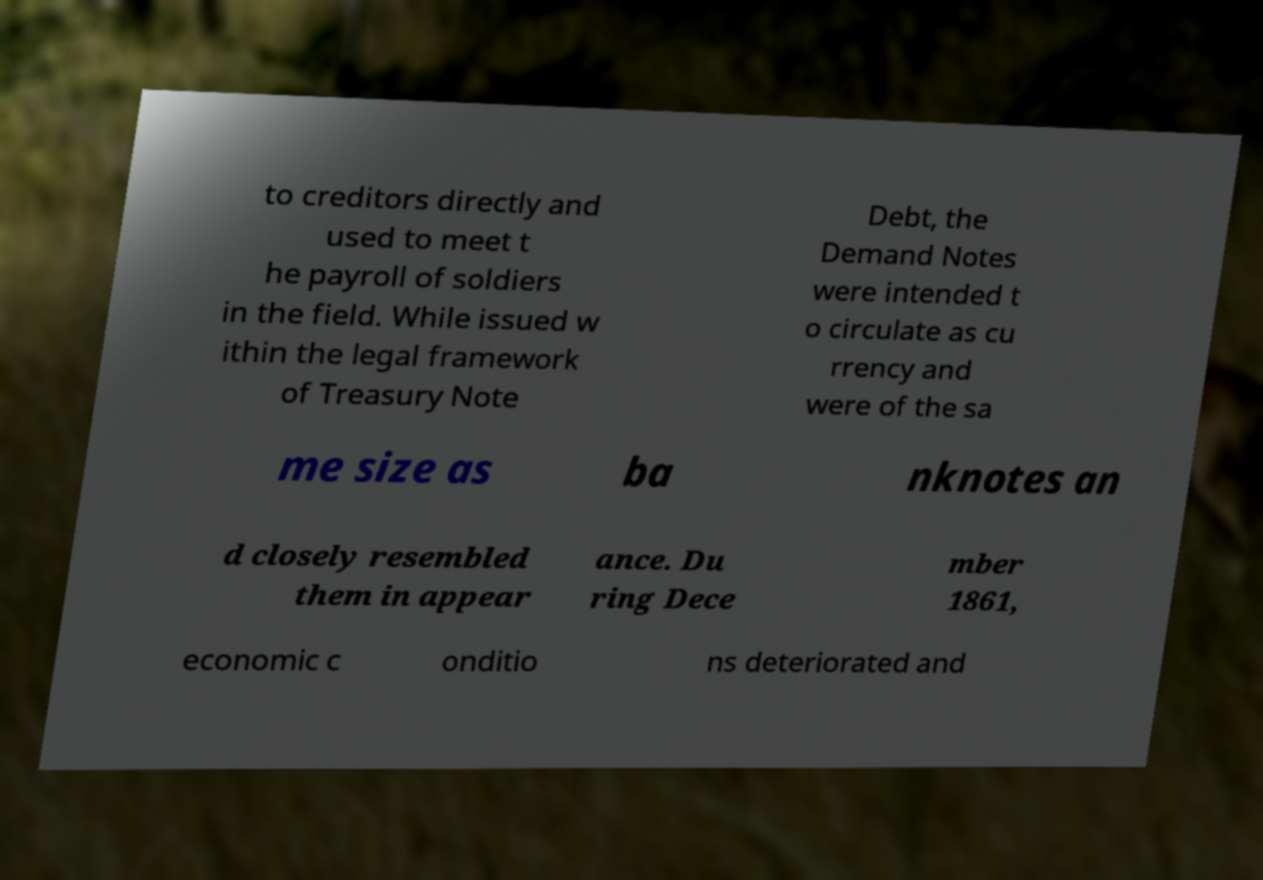Please identify and transcribe the text found in this image. to creditors directly and used to meet t he payroll of soldiers in the field. While issued w ithin the legal framework of Treasury Note Debt, the Demand Notes were intended t o circulate as cu rrency and were of the sa me size as ba nknotes an d closely resembled them in appear ance. Du ring Dece mber 1861, economic c onditio ns deteriorated and 